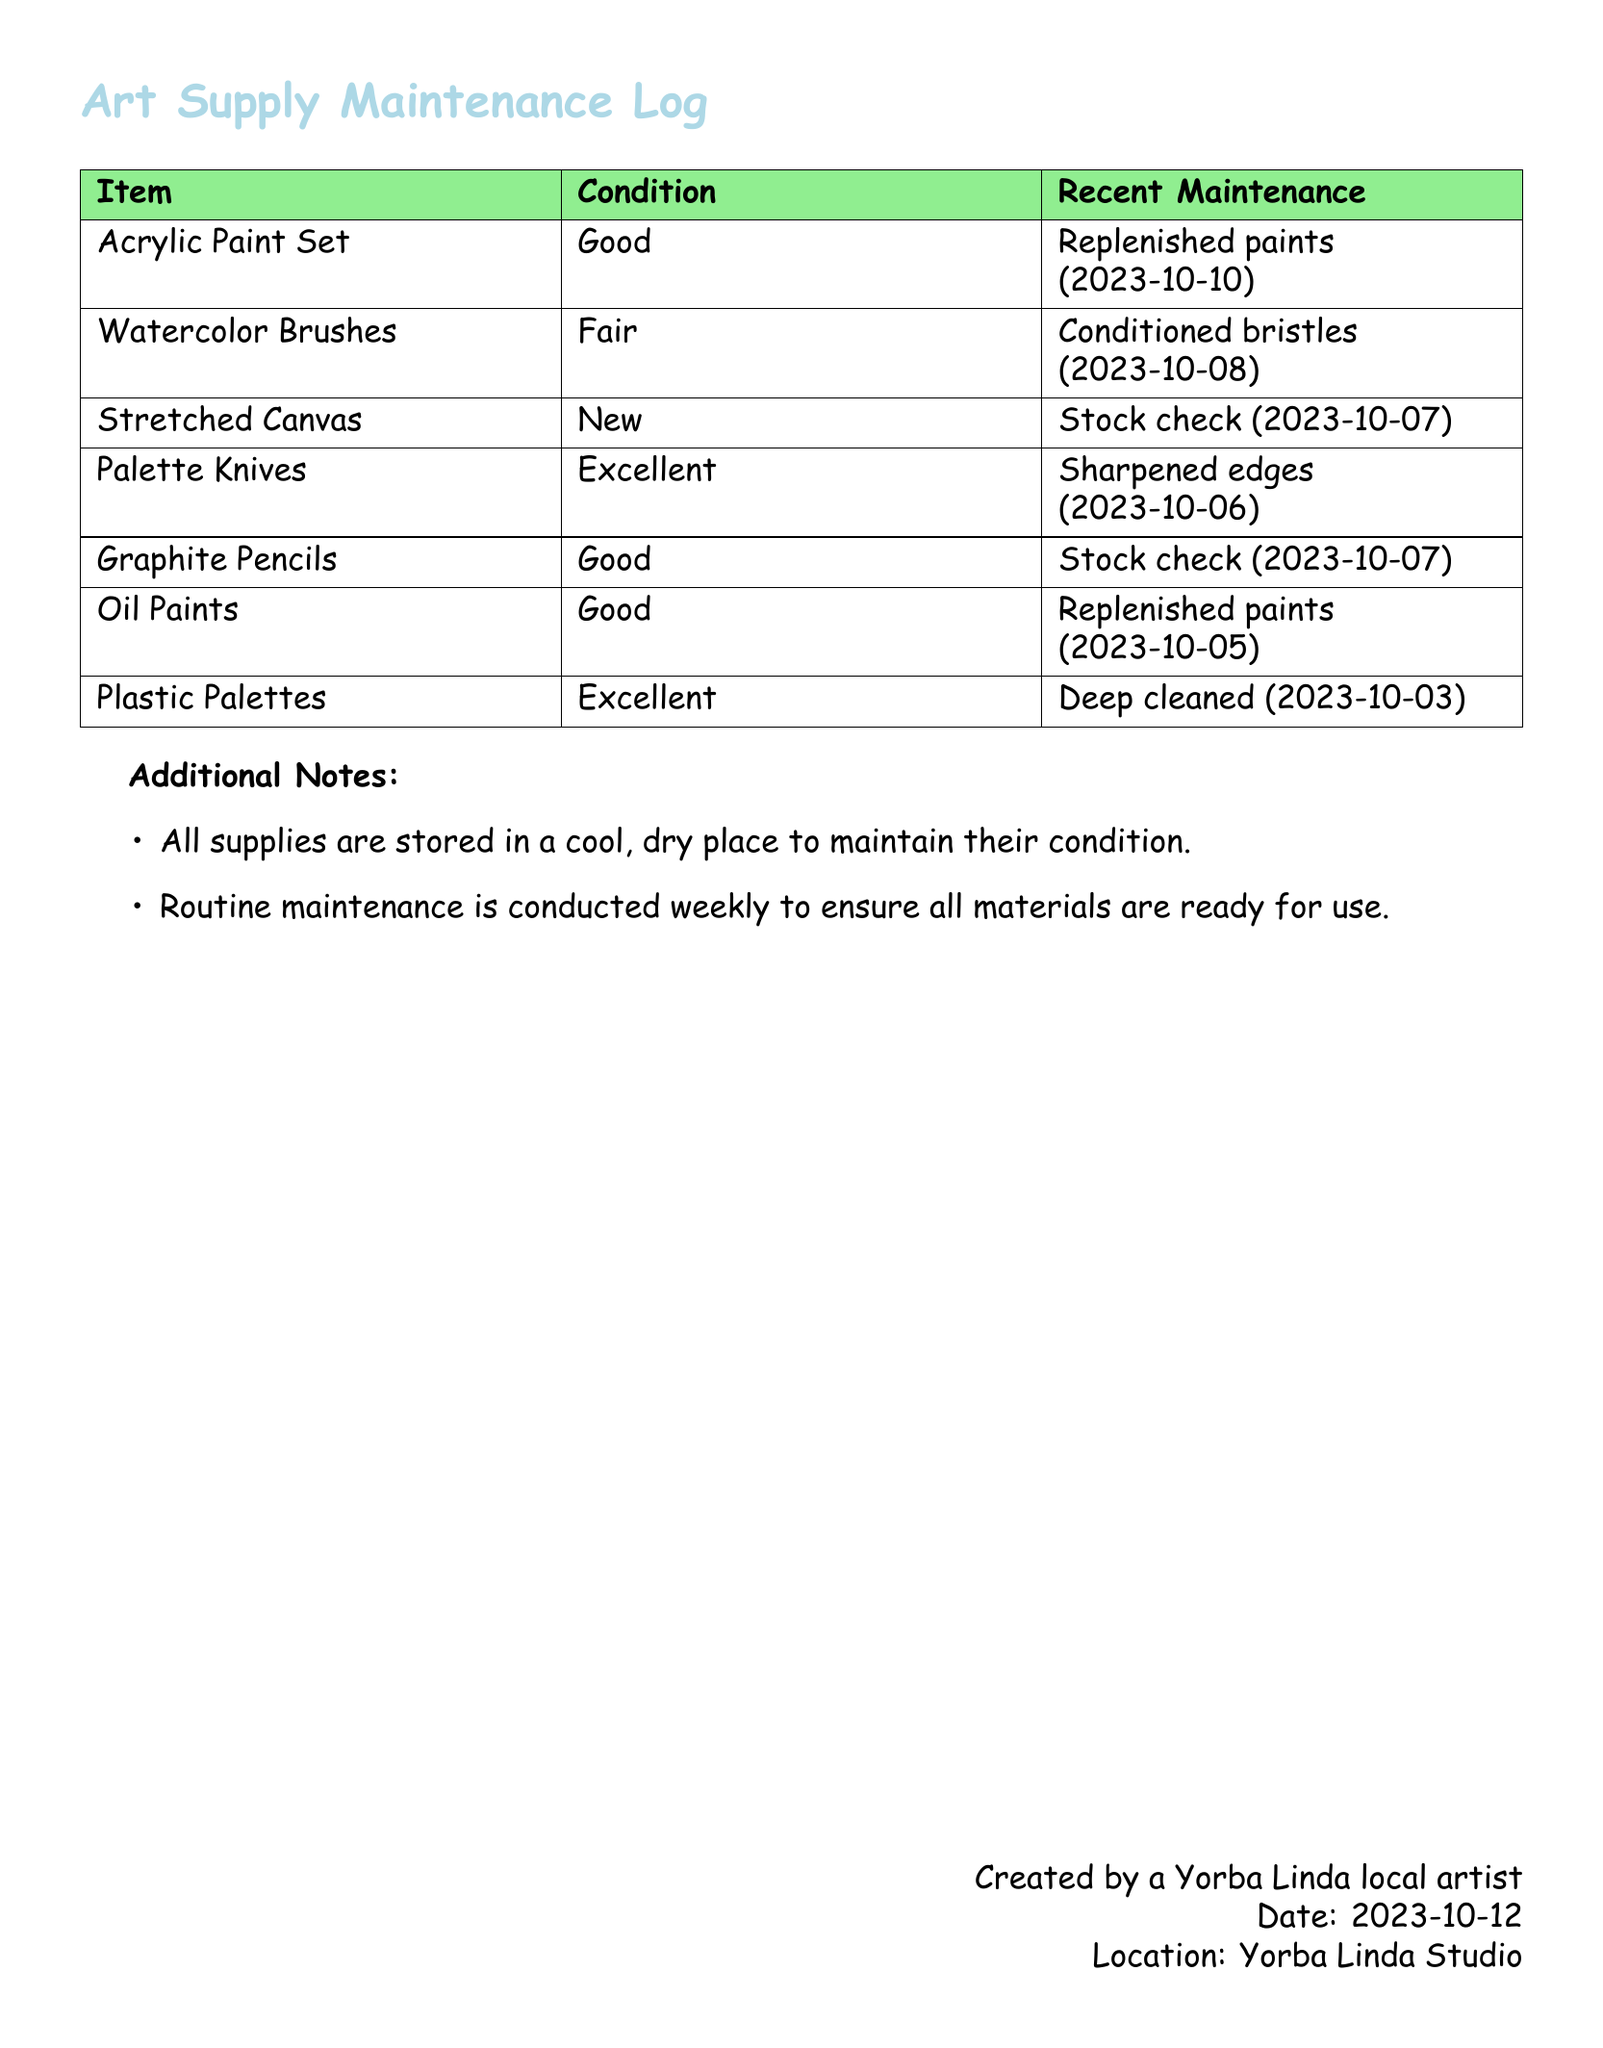What is the condition of the Watercolor Brushes? The condition is specified in the document under the 'Condition' column for the Watercolor Brushes.
Answer: Fair When was the last maintenance for the Acrylic Paint Set? The date of the last maintenance for the Acrylic Paint Set is documented in the 'Recent Maintenance' column.
Answer: 2023-10-10 How many items have a condition labeled as 'Excellent'? This requires counting items across the document in the 'Condition' column that are marked as 'Excellent'.
Answer: 2 What maintenance action was taken for the Plastic Palettes? The maintenance action described for the Plastic Palettes is found in the 'Recent Maintenance' column.
Answer: Deep cleaned Which item was last maintained on 2023-10-08? The date is used to find the corresponding item in the 'Recent Maintenance' column.
Answer: Watercolor Brushes 